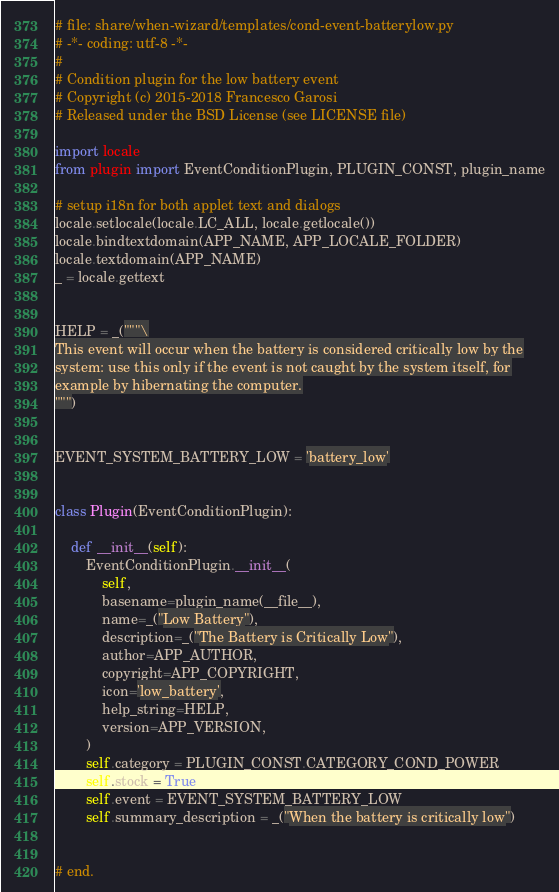Convert code to text. <code><loc_0><loc_0><loc_500><loc_500><_Python_># file: share/when-wizard/templates/cond-event-batterylow.py
# -*- coding: utf-8 -*-
#
# Condition plugin for the low battery event
# Copyright (c) 2015-2018 Francesco Garosi
# Released under the BSD License (see LICENSE file)

import locale
from plugin import EventConditionPlugin, PLUGIN_CONST, plugin_name

# setup i18n for both applet text and dialogs
locale.setlocale(locale.LC_ALL, locale.getlocale())
locale.bindtextdomain(APP_NAME, APP_LOCALE_FOLDER)
locale.textdomain(APP_NAME)
_ = locale.gettext


HELP = _("""\
This event will occur when the battery is considered critically low by the
system: use this only if the event is not caught by the system itself, for
example by hibernating the computer.
""")


EVENT_SYSTEM_BATTERY_LOW = 'battery_low'


class Plugin(EventConditionPlugin):

    def __init__(self):
        EventConditionPlugin.__init__(
            self,
            basename=plugin_name(__file__),
            name=_("Low Battery"),
            description=_("The Battery is Critically Low"),
            author=APP_AUTHOR,
            copyright=APP_COPYRIGHT,
            icon='low_battery',
            help_string=HELP,
            version=APP_VERSION,
        )
        self.category = PLUGIN_CONST.CATEGORY_COND_POWER
        self.stock = True
        self.event = EVENT_SYSTEM_BATTERY_LOW
        self.summary_description = _("When the battery is critically low")


# end.
</code> 